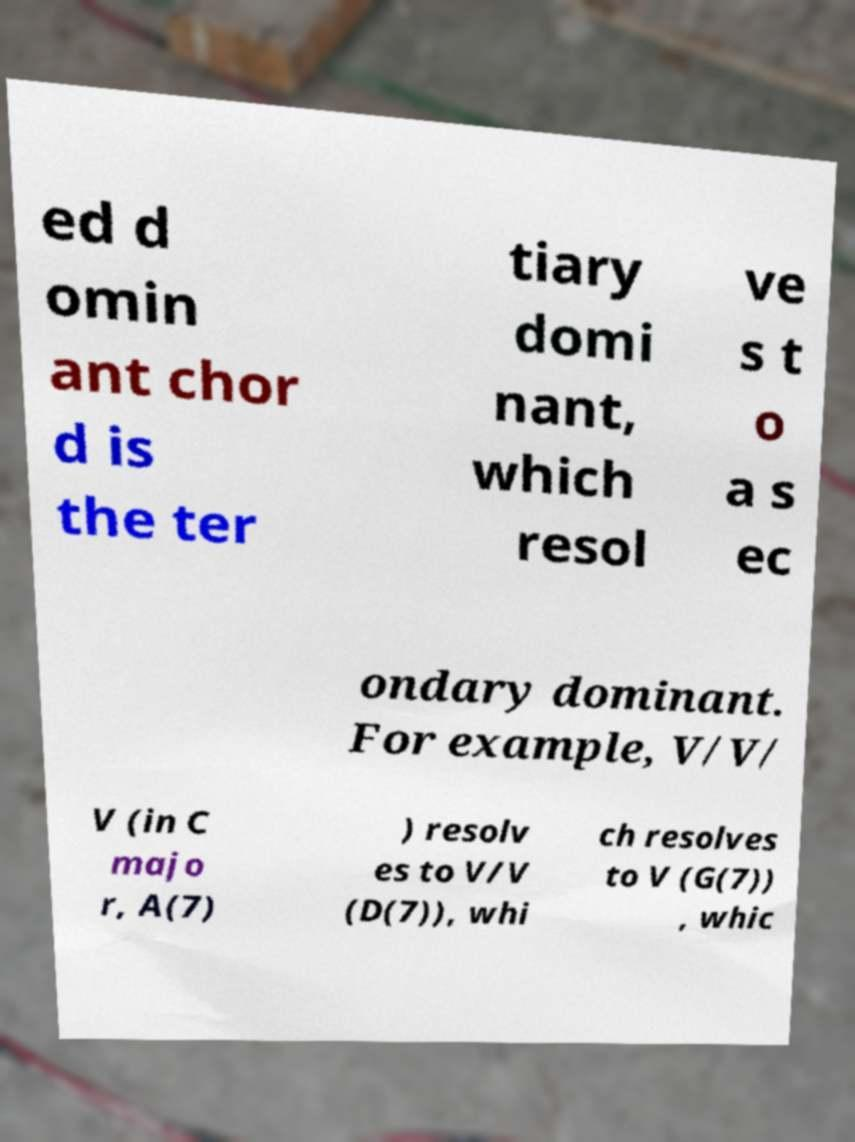What messages or text are displayed in this image? I need them in a readable, typed format. ed d omin ant chor d is the ter tiary domi nant, which resol ve s t o a s ec ondary dominant. For example, V/V/ V (in C majo r, A(7) ) resolv es to V/V (D(7)), whi ch resolves to V (G(7)) , whic 